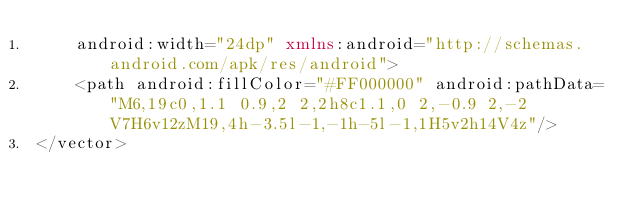<code> <loc_0><loc_0><loc_500><loc_500><_XML_>    android:width="24dp" xmlns:android="http://schemas.android.com/apk/res/android">
    <path android:fillColor="#FF000000" android:pathData="M6,19c0,1.1 0.9,2 2,2h8c1.1,0 2,-0.9 2,-2V7H6v12zM19,4h-3.5l-1,-1h-5l-1,1H5v2h14V4z"/>
</vector>
</code> 